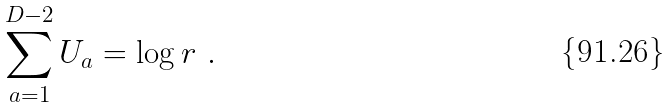Convert formula to latex. <formula><loc_0><loc_0><loc_500><loc_500>\sum _ { a = 1 } ^ { D - 2 } U _ { a } = \log r \ .</formula> 